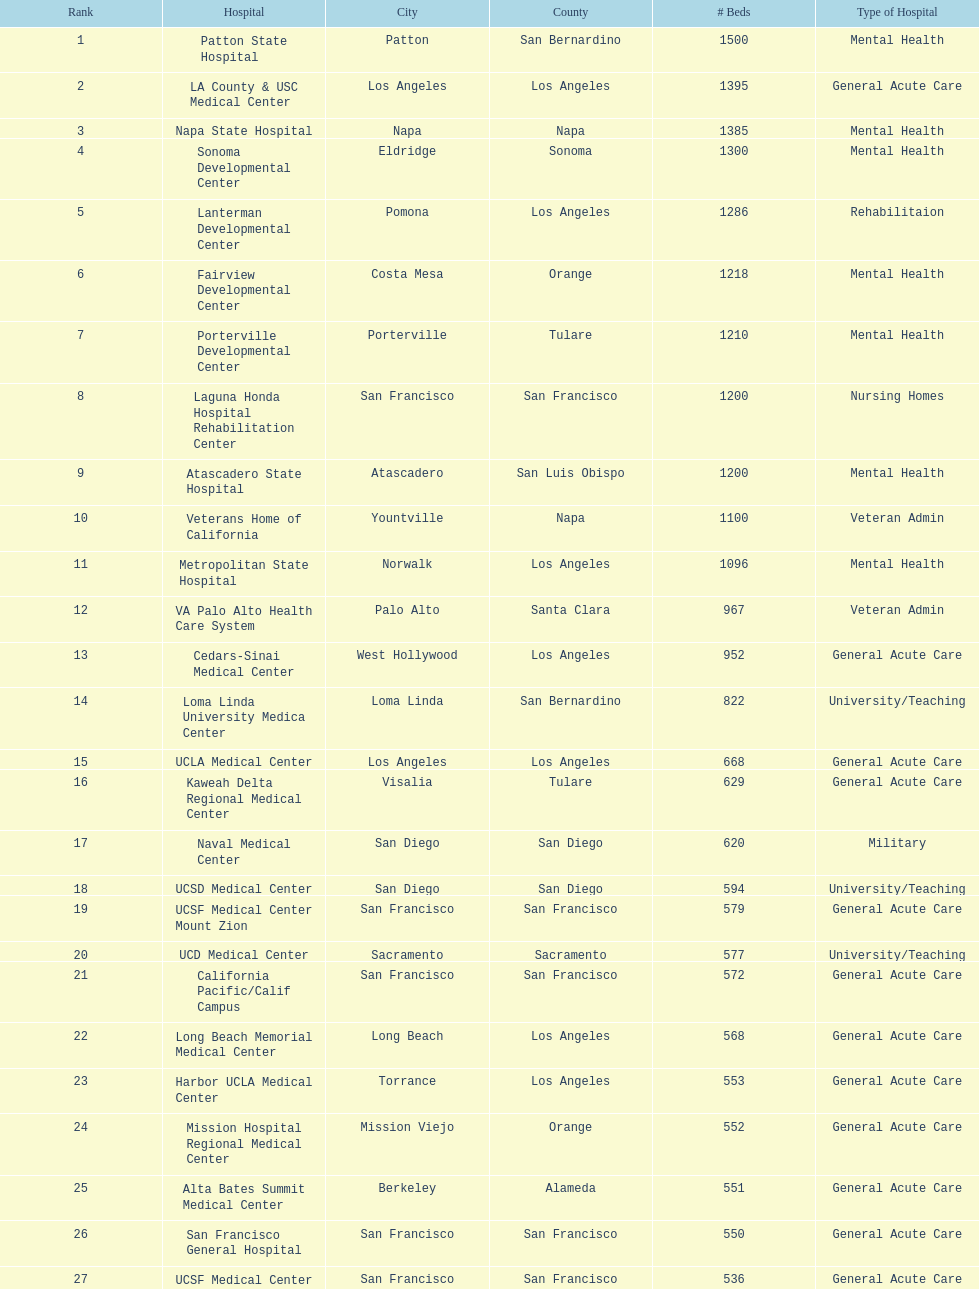Is the number of mental health hospital beds at patton state hospital in san bernardino county greater than those at atascadero state hospital in san luis obispo county? Yes. 